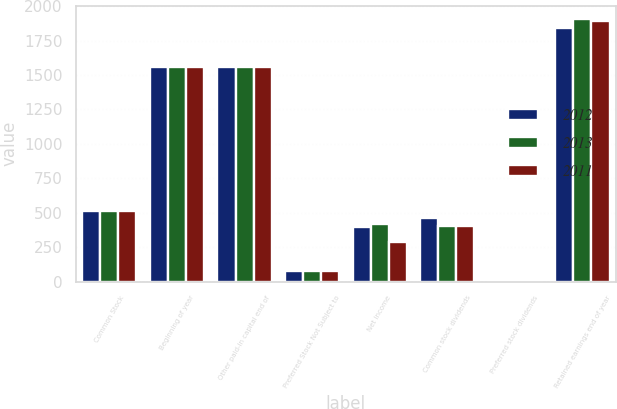Convert chart. <chart><loc_0><loc_0><loc_500><loc_500><stacked_bar_chart><ecel><fcel>Common Stock<fcel>Beginning of year<fcel>Other paid-in capital end of<fcel>Preferred Stock Not Subject to<fcel>Net income<fcel>Common stock dividends<fcel>Preferred stock dividends<fcel>Retained earnings end of year<nl><fcel>2012<fcel>511<fcel>1556<fcel>1560<fcel>80<fcel>398<fcel>460<fcel>3<fcel>1842<nl><fcel>2013<fcel>511<fcel>1555<fcel>1556<fcel>80<fcel>419<fcel>400<fcel>3<fcel>1907<nl><fcel>2011<fcel>511<fcel>1555<fcel>1555<fcel>80<fcel>290<fcel>403<fcel>3<fcel>1891<nl></chart> 